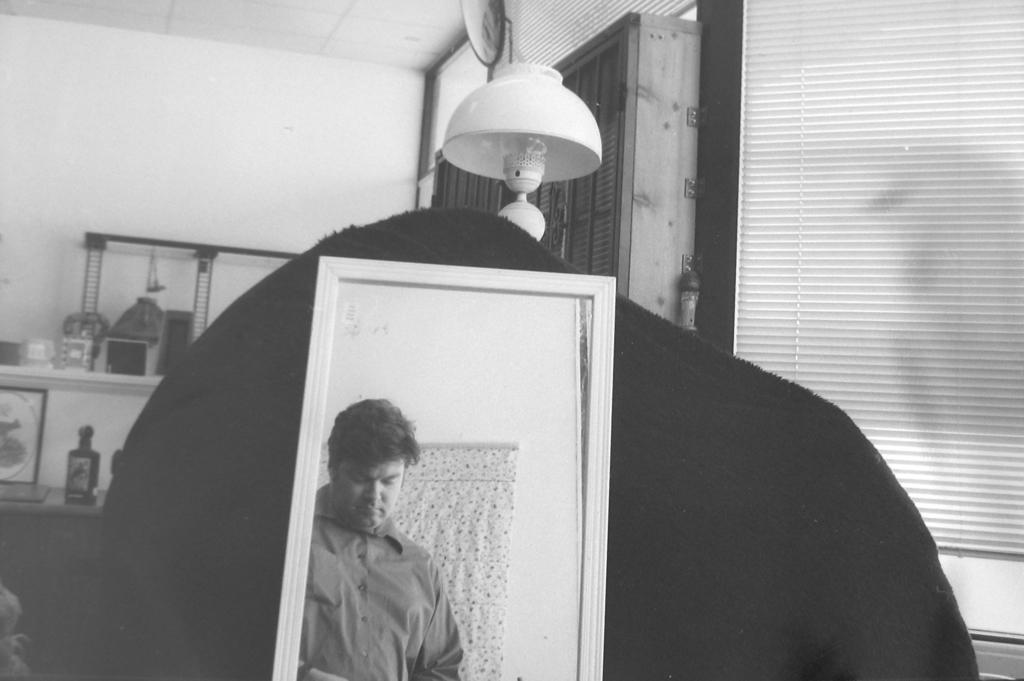Please provide a concise description of this image. In this picture there is a mirror which has a person standing in front of it and there is an object behind the mirror and there is a lamp and some other objects in the background. 